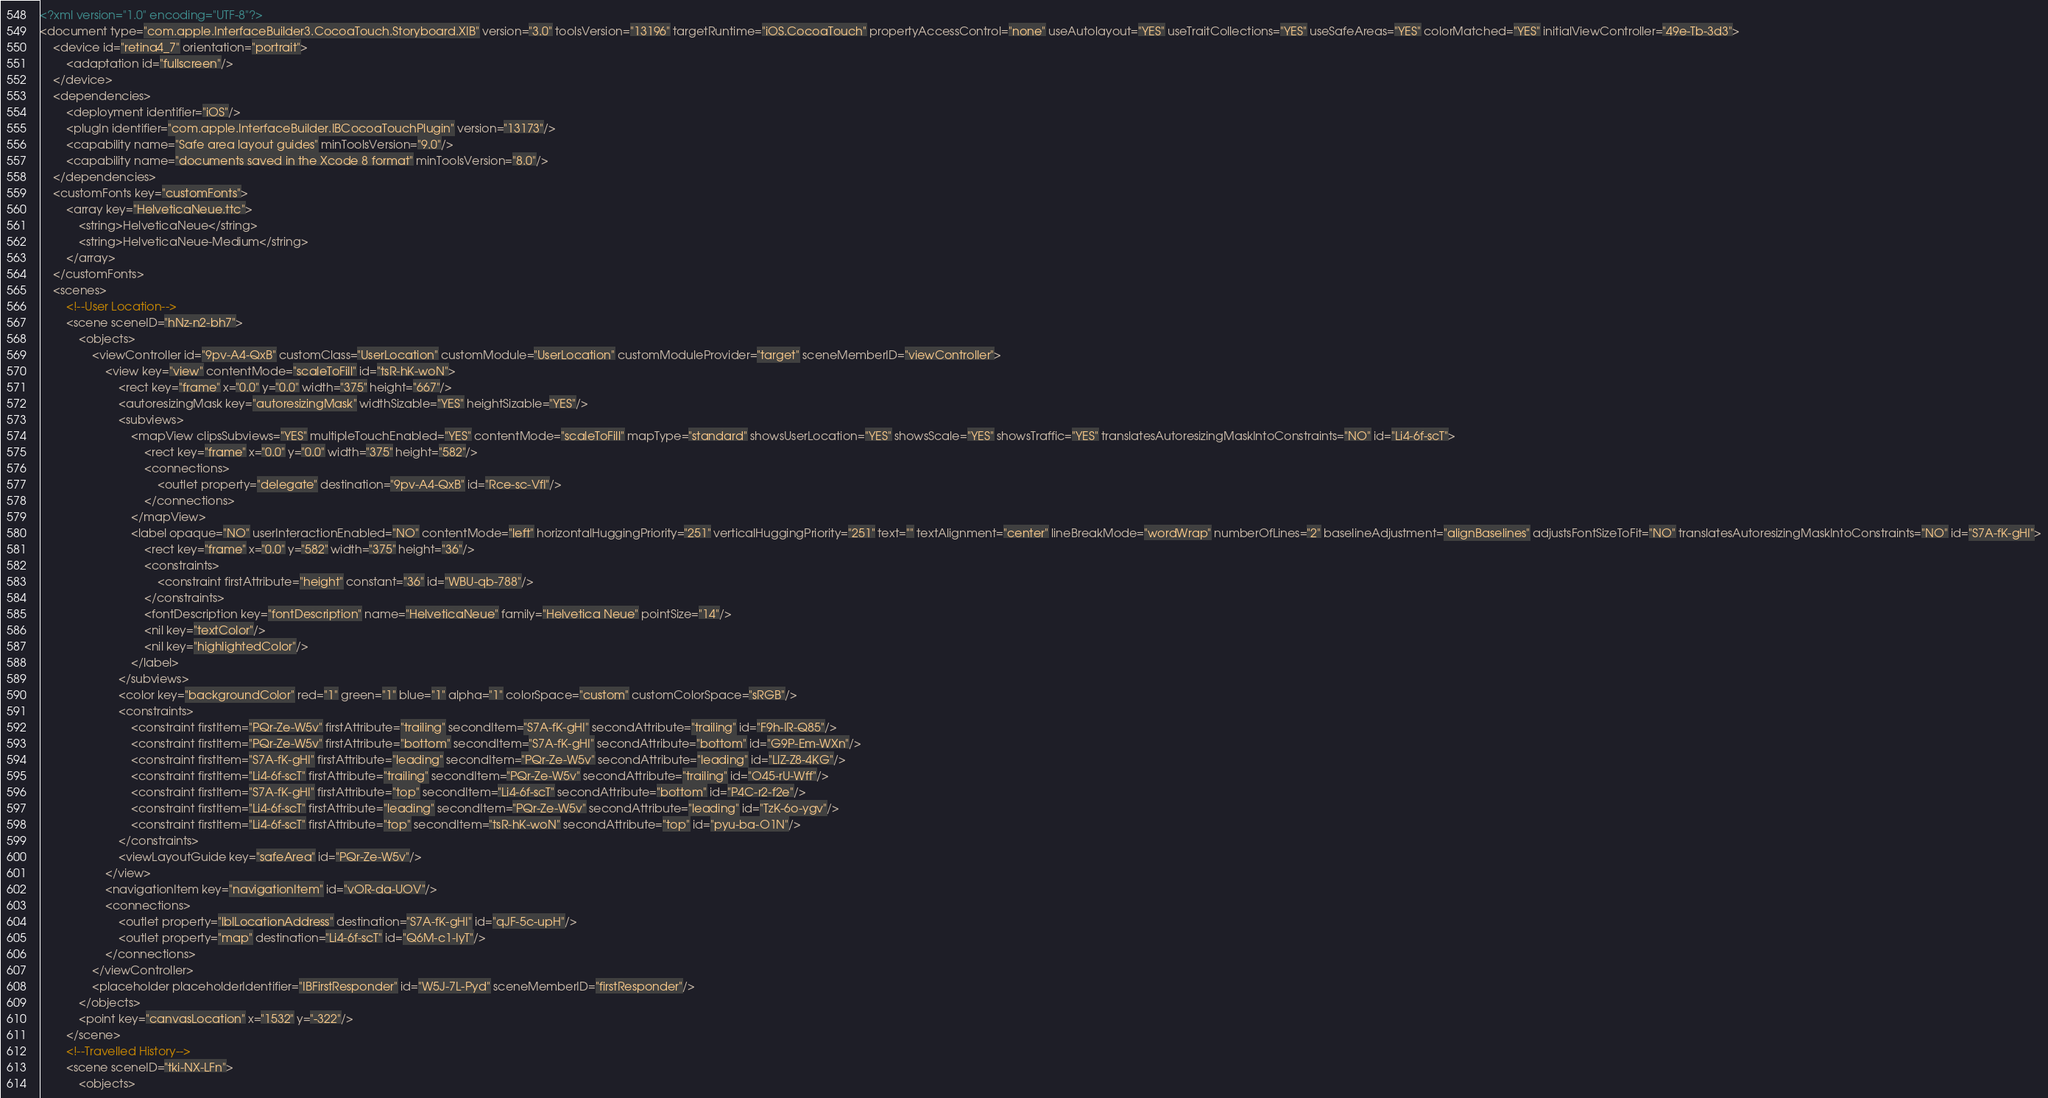Convert code to text. <code><loc_0><loc_0><loc_500><loc_500><_XML_><?xml version="1.0" encoding="UTF-8"?>
<document type="com.apple.InterfaceBuilder3.CocoaTouch.Storyboard.XIB" version="3.0" toolsVersion="13196" targetRuntime="iOS.CocoaTouch" propertyAccessControl="none" useAutolayout="YES" useTraitCollections="YES" useSafeAreas="YES" colorMatched="YES" initialViewController="49e-Tb-3d3">
    <device id="retina4_7" orientation="portrait">
        <adaptation id="fullscreen"/>
    </device>
    <dependencies>
        <deployment identifier="iOS"/>
        <plugIn identifier="com.apple.InterfaceBuilder.IBCocoaTouchPlugin" version="13173"/>
        <capability name="Safe area layout guides" minToolsVersion="9.0"/>
        <capability name="documents saved in the Xcode 8 format" minToolsVersion="8.0"/>
    </dependencies>
    <customFonts key="customFonts">
        <array key="HelveticaNeue.ttc">
            <string>HelveticaNeue</string>
            <string>HelveticaNeue-Medium</string>
        </array>
    </customFonts>
    <scenes>
        <!--User Location-->
        <scene sceneID="hNz-n2-bh7">
            <objects>
                <viewController id="9pv-A4-QxB" customClass="UserLocation" customModule="UserLocation" customModuleProvider="target" sceneMemberID="viewController">
                    <view key="view" contentMode="scaleToFill" id="tsR-hK-woN">
                        <rect key="frame" x="0.0" y="0.0" width="375" height="667"/>
                        <autoresizingMask key="autoresizingMask" widthSizable="YES" heightSizable="YES"/>
                        <subviews>
                            <mapView clipsSubviews="YES" multipleTouchEnabled="YES" contentMode="scaleToFill" mapType="standard" showsUserLocation="YES" showsScale="YES" showsTraffic="YES" translatesAutoresizingMaskIntoConstraints="NO" id="Li4-6f-scT">
                                <rect key="frame" x="0.0" y="0.0" width="375" height="582"/>
                                <connections>
                                    <outlet property="delegate" destination="9pv-A4-QxB" id="Rce-sc-VfI"/>
                                </connections>
                            </mapView>
                            <label opaque="NO" userInteractionEnabled="NO" contentMode="left" horizontalHuggingPriority="251" verticalHuggingPriority="251" text="" textAlignment="center" lineBreakMode="wordWrap" numberOfLines="2" baselineAdjustment="alignBaselines" adjustsFontSizeToFit="NO" translatesAutoresizingMaskIntoConstraints="NO" id="S7A-fK-gHI">
                                <rect key="frame" x="0.0" y="582" width="375" height="36"/>
                                <constraints>
                                    <constraint firstAttribute="height" constant="36" id="WBU-qb-788"/>
                                </constraints>
                                <fontDescription key="fontDescription" name="HelveticaNeue" family="Helvetica Neue" pointSize="14"/>
                                <nil key="textColor"/>
                                <nil key="highlightedColor"/>
                            </label>
                        </subviews>
                        <color key="backgroundColor" red="1" green="1" blue="1" alpha="1" colorSpace="custom" customColorSpace="sRGB"/>
                        <constraints>
                            <constraint firstItem="PQr-Ze-W5v" firstAttribute="trailing" secondItem="S7A-fK-gHI" secondAttribute="trailing" id="F9h-IR-Q85"/>
                            <constraint firstItem="PQr-Ze-W5v" firstAttribute="bottom" secondItem="S7A-fK-gHI" secondAttribute="bottom" id="G9P-Em-WXn"/>
                            <constraint firstItem="S7A-fK-gHI" firstAttribute="leading" secondItem="PQr-Ze-W5v" secondAttribute="leading" id="LlZ-Z8-4KG"/>
                            <constraint firstItem="Li4-6f-scT" firstAttribute="trailing" secondItem="PQr-Ze-W5v" secondAttribute="trailing" id="O45-rU-Wff"/>
                            <constraint firstItem="S7A-fK-gHI" firstAttribute="top" secondItem="Li4-6f-scT" secondAttribute="bottom" id="P4C-r2-f2e"/>
                            <constraint firstItem="Li4-6f-scT" firstAttribute="leading" secondItem="PQr-Ze-W5v" secondAttribute="leading" id="TzK-6o-ygv"/>
                            <constraint firstItem="Li4-6f-scT" firstAttribute="top" secondItem="tsR-hK-woN" secondAttribute="top" id="pyu-ba-O1N"/>
                        </constraints>
                        <viewLayoutGuide key="safeArea" id="PQr-Ze-W5v"/>
                    </view>
                    <navigationItem key="navigationItem" id="vOR-da-UOV"/>
                    <connections>
                        <outlet property="lblLocationAddress" destination="S7A-fK-gHI" id="qJF-5c-upH"/>
                        <outlet property="map" destination="Li4-6f-scT" id="Q6M-c1-IyT"/>
                    </connections>
                </viewController>
                <placeholder placeholderIdentifier="IBFirstResponder" id="W5J-7L-Pyd" sceneMemberID="firstResponder"/>
            </objects>
            <point key="canvasLocation" x="1532" y="-322"/>
        </scene>
        <!--Travelled History-->
        <scene sceneID="tki-NX-LFn">
            <objects></code> 